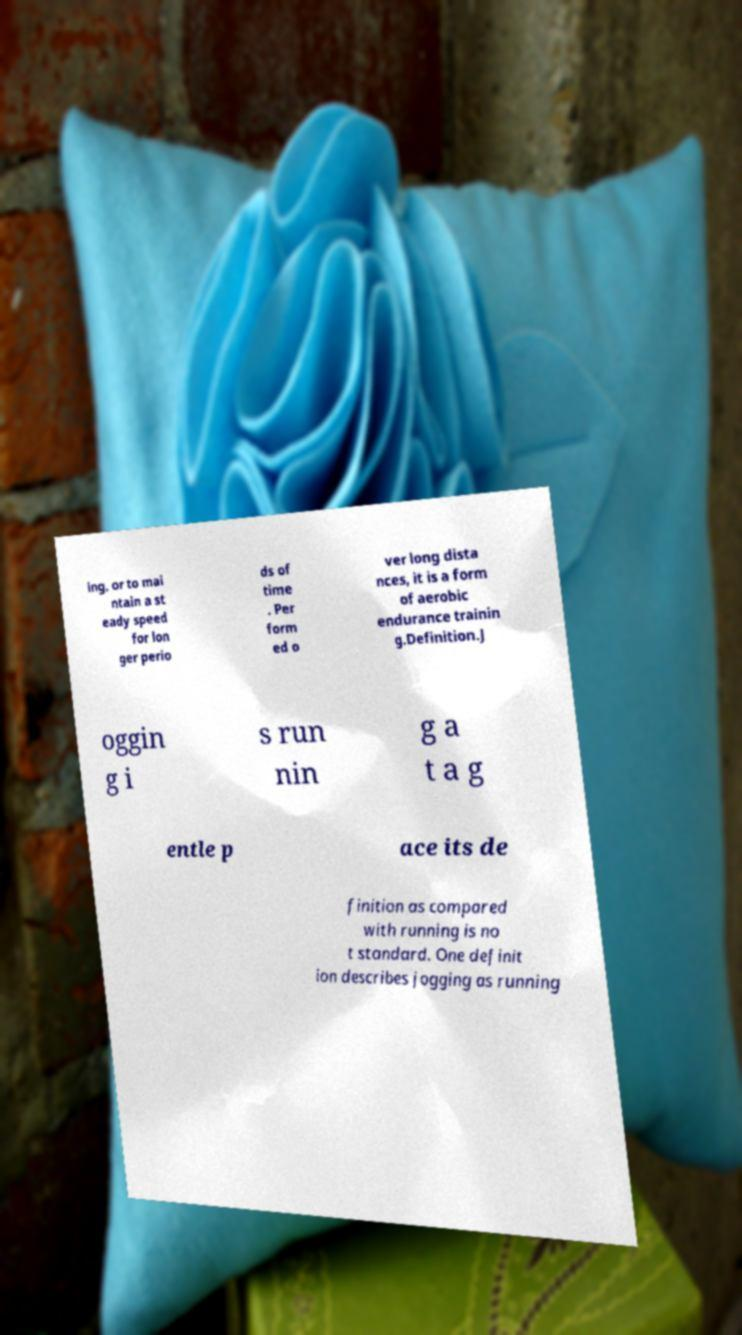Please read and relay the text visible in this image. What does it say? ing, or to mai ntain a st eady speed for lon ger perio ds of time . Per form ed o ver long dista nces, it is a form of aerobic endurance trainin g.Definition.J oggin g i s run nin g a t a g entle p ace its de finition as compared with running is no t standard. One definit ion describes jogging as running 